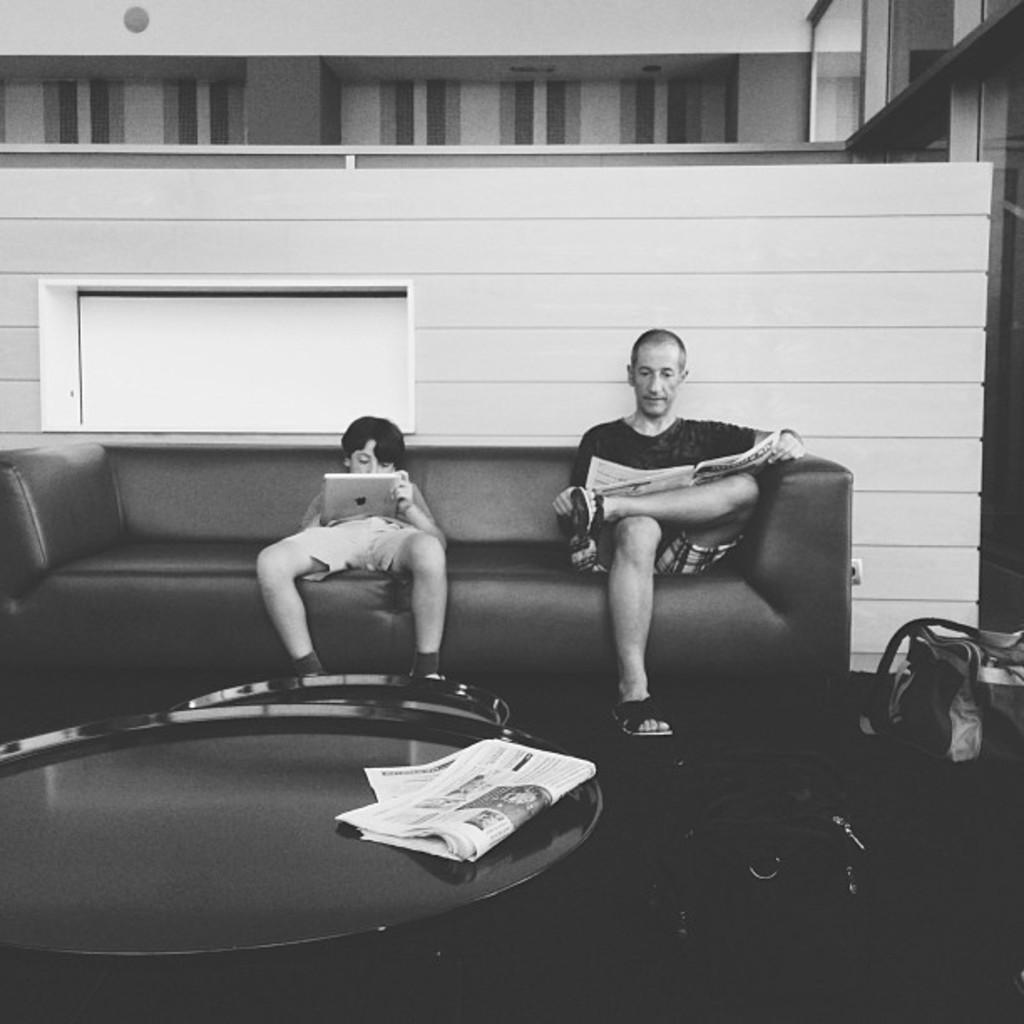In one or two sentences, can you explain what this image depicts? In this image I can see two people sitting on the couch. In front of them there is a teapoy. On the teapoy there is a paper. And there is a bag on the floor. 